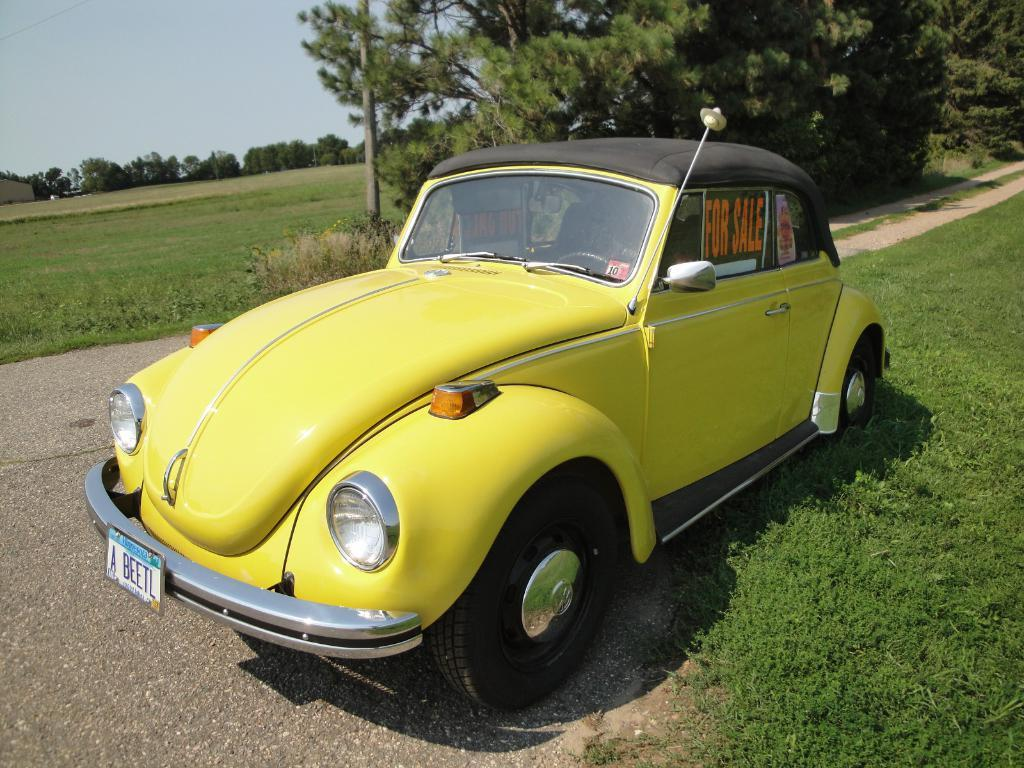What is located on the ground in the image? There is a car on the ground in the image. What is on the car? There are posters on the car. What type of vegetation can be seen in the image? There is grass visible in the image, and there are also trees. What other object can be seen in the image? There is a pole in the image. What is visible in the background of the image? The sky is visible in the background of the image. What type of pencil can be seen in the image? There is no pencil present in the image. What material is the leather on the car made of? There is no leather present in the image. --- Facts: 1. There is a person sitting on a bench in the image. 2. The person is reading a book. 3. There is a tree behind the bench. 4. The ground is visible in the image. 5. There is a fence in the image. Absurd Topics: parrot, sand, bicycle Conversation: What is the person in the image doing? The person is sitting on a bench in the image and reading a book. What is located behind the bench? There is a tree behind the bench. What can be seen on the ground in the image? The ground is visible in the image. What type of barrier is present in the image? There is a fence in the image. Reasoning: Let's think step by step in order to produce the conversation. We start by identifying the main subject in the image, which is the person sitting on the bench. Then, we expand the conversation to include other items that are also visible, such as the book, tree, ground, and fence. Each question is designed to elicit a specific detail about the image that is known from the provided facts. Absurd Question/Answer: What type of parrot can be seen sitting on the fence in the image? There is no parrot present in the image. What type of sand can be seen on the ground in the image? There is no sand present in the image; the ground is not sandy. 